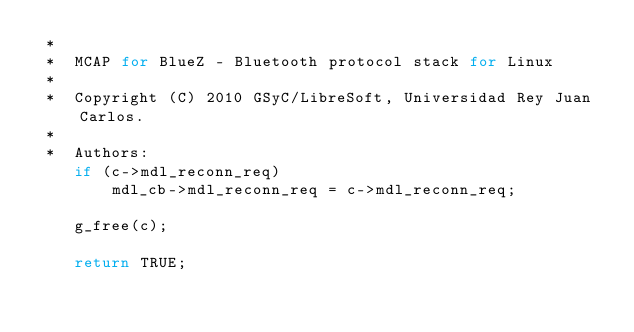<code> <loc_0><loc_0><loc_500><loc_500><_C_> *
 *  MCAP for BlueZ - Bluetooth protocol stack for Linux
 *
 *  Copyright (C) 2010 GSyC/LibreSoft, Universidad Rey Juan Carlos.
 *
 *  Authors:
	if (c->mdl_reconn_req)
		mdl_cb->mdl_reconn_req = c->mdl_reconn_req;

	g_free(c);

	return TRUE;</code> 